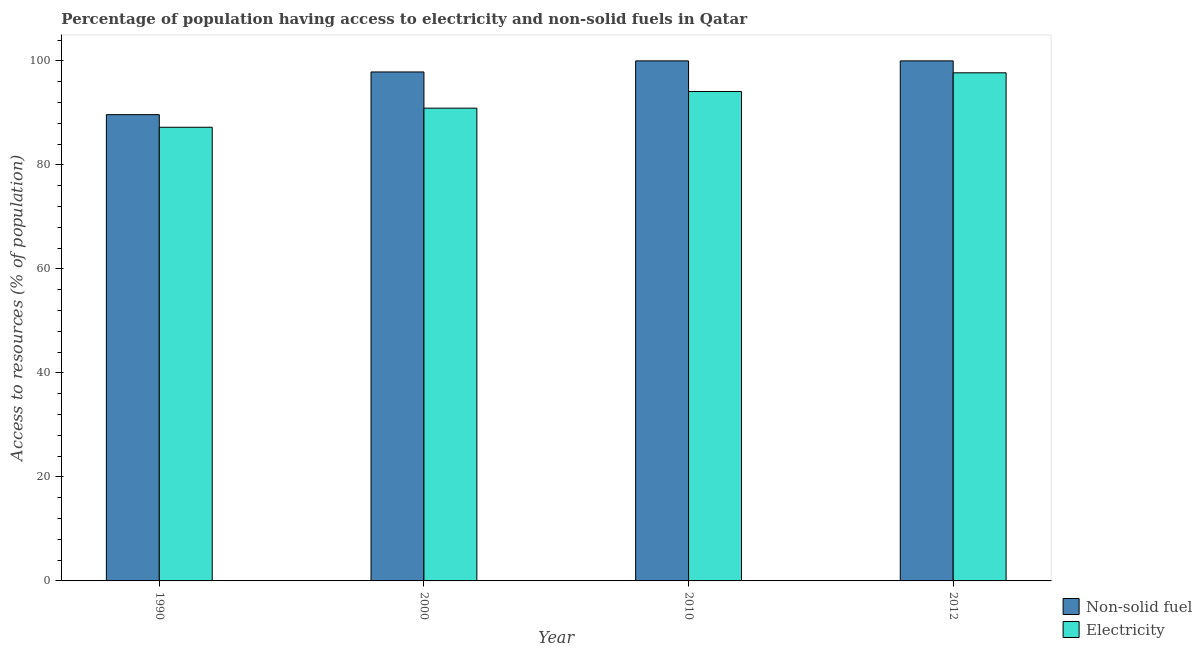How many bars are there on the 3rd tick from the left?
Keep it short and to the point. 2. What is the label of the 1st group of bars from the left?
Make the answer very short. 1990. In how many cases, is the number of bars for a given year not equal to the number of legend labels?
Keep it short and to the point. 0. What is the percentage of population having access to electricity in 2000?
Provide a short and direct response. 90.9. Across all years, what is the maximum percentage of population having access to non-solid fuel?
Your response must be concise. 99.99. Across all years, what is the minimum percentage of population having access to electricity?
Provide a short and direct response. 87.23. What is the total percentage of population having access to non-solid fuel in the graph?
Ensure brevity in your answer.  387.49. What is the difference between the percentage of population having access to non-solid fuel in 2010 and that in 2012?
Keep it short and to the point. 0. What is the difference between the percentage of population having access to non-solid fuel in 1990 and the percentage of population having access to electricity in 2000?
Your answer should be compact. -8.21. What is the average percentage of population having access to non-solid fuel per year?
Your response must be concise. 96.87. In how many years, is the percentage of population having access to electricity greater than 40 %?
Provide a succinct answer. 4. What is the ratio of the percentage of population having access to non-solid fuel in 2000 to that in 2012?
Provide a succinct answer. 0.98. Is the difference between the percentage of population having access to non-solid fuel in 1990 and 2000 greater than the difference between the percentage of population having access to electricity in 1990 and 2000?
Make the answer very short. No. What is the difference between the highest and the second highest percentage of population having access to electricity?
Make the answer very short. 3.6. What is the difference between the highest and the lowest percentage of population having access to electricity?
Provide a short and direct response. 10.47. What does the 2nd bar from the left in 1990 represents?
Give a very brief answer. Electricity. What does the 2nd bar from the right in 1990 represents?
Your response must be concise. Non-solid fuel. How many years are there in the graph?
Offer a terse response. 4. What is the difference between two consecutive major ticks on the Y-axis?
Give a very brief answer. 20. Does the graph contain grids?
Ensure brevity in your answer.  No. Where does the legend appear in the graph?
Offer a terse response. Bottom right. How are the legend labels stacked?
Provide a short and direct response. Vertical. What is the title of the graph?
Give a very brief answer. Percentage of population having access to electricity and non-solid fuels in Qatar. What is the label or title of the X-axis?
Ensure brevity in your answer.  Year. What is the label or title of the Y-axis?
Ensure brevity in your answer.  Access to resources (% of population). What is the Access to resources (% of population) in Non-solid fuel in 1990?
Offer a terse response. 89.65. What is the Access to resources (% of population) of Electricity in 1990?
Keep it short and to the point. 87.23. What is the Access to resources (% of population) of Non-solid fuel in 2000?
Your answer should be compact. 97.86. What is the Access to resources (% of population) of Electricity in 2000?
Offer a very short reply. 90.9. What is the Access to resources (% of population) of Non-solid fuel in 2010?
Give a very brief answer. 99.99. What is the Access to resources (% of population) in Electricity in 2010?
Your answer should be compact. 94.1. What is the Access to resources (% of population) in Non-solid fuel in 2012?
Provide a short and direct response. 99.99. What is the Access to resources (% of population) of Electricity in 2012?
Keep it short and to the point. 97.7. Across all years, what is the maximum Access to resources (% of population) in Non-solid fuel?
Offer a very short reply. 99.99. Across all years, what is the maximum Access to resources (% of population) in Electricity?
Offer a terse response. 97.7. Across all years, what is the minimum Access to resources (% of population) in Non-solid fuel?
Offer a terse response. 89.65. Across all years, what is the minimum Access to resources (% of population) in Electricity?
Ensure brevity in your answer.  87.23. What is the total Access to resources (% of population) of Non-solid fuel in the graph?
Give a very brief answer. 387.49. What is the total Access to resources (% of population) in Electricity in the graph?
Give a very brief answer. 369.92. What is the difference between the Access to resources (% of population) of Non-solid fuel in 1990 and that in 2000?
Your answer should be compact. -8.21. What is the difference between the Access to resources (% of population) in Electricity in 1990 and that in 2000?
Keep it short and to the point. -3.67. What is the difference between the Access to resources (% of population) in Non-solid fuel in 1990 and that in 2010?
Give a very brief answer. -10.34. What is the difference between the Access to resources (% of population) in Electricity in 1990 and that in 2010?
Give a very brief answer. -6.87. What is the difference between the Access to resources (% of population) of Non-solid fuel in 1990 and that in 2012?
Your response must be concise. -10.34. What is the difference between the Access to resources (% of population) of Electricity in 1990 and that in 2012?
Make the answer very short. -10.47. What is the difference between the Access to resources (% of population) in Non-solid fuel in 2000 and that in 2010?
Offer a very short reply. -2.13. What is the difference between the Access to resources (% of population) in Electricity in 2000 and that in 2010?
Provide a succinct answer. -3.2. What is the difference between the Access to resources (% of population) in Non-solid fuel in 2000 and that in 2012?
Keep it short and to the point. -2.13. What is the difference between the Access to resources (% of population) of Electricity in 2000 and that in 2012?
Your answer should be compact. -6.8. What is the difference between the Access to resources (% of population) of Non-solid fuel in 2010 and that in 2012?
Give a very brief answer. 0. What is the difference between the Access to resources (% of population) in Electricity in 2010 and that in 2012?
Ensure brevity in your answer.  -3.6. What is the difference between the Access to resources (% of population) in Non-solid fuel in 1990 and the Access to resources (% of population) in Electricity in 2000?
Provide a short and direct response. -1.25. What is the difference between the Access to resources (% of population) in Non-solid fuel in 1990 and the Access to resources (% of population) in Electricity in 2010?
Provide a short and direct response. -4.45. What is the difference between the Access to resources (% of population) in Non-solid fuel in 1990 and the Access to resources (% of population) in Electricity in 2012?
Provide a succinct answer. -8.05. What is the difference between the Access to resources (% of population) in Non-solid fuel in 2000 and the Access to resources (% of population) in Electricity in 2010?
Your answer should be compact. 3.76. What is the difference between the Access to resources (% of population) of Non-solid fuel in 2000 and the Access to resources (% of population) of Electricity in 2012?
Give a very brief answer. 0.16. What is the difference between the Access to resources (% of population) of Non-solid fuel in 2010 and the Access to resources (% of population) of Electricity in 2012?
Offer a terse response. 2.29. What is the average Access to resources (% of population) in Non-solid fuel per year?
Your response must be concise. 96.87. What is the average Access to resources (% of population) of Electricity per year?
Offer a terse response. 92.48. In the year 1990, what is the difference between the Access to resources (% of population) in Non-solid fuel and Access to resources (% of population) in Electricity?
Provide a short and direct response. 2.42. In the year 2000, what is the difference between the Access to resources (% of population) in Non-solid fuel and Access to resources (% of population) in Electricity?
Offer a very short reply. 6.96. In the year 2010, what is the difference between the Access to resources (% of population) in Non-solid fuel and Access to resources (% of population) in Electricity?
Your response must be concise. 5.89. In the year 2012, what is the difference between the Access to resources (% of population) in Non-solid fuel and Access to resources (% of population) in Electricity?
Ensure brevity in your answer.  2.29. What is the ratio of the Access to resources (% of population) of Non-solid fuel in 1990 to that in 2000?
Make the answer very short. 0.92. What is the ratio of the Access to resources (% of population) of Electricity in 1990 to that in 2000?
Your response must be concise. 0.96. What is the ratio of the Access to resources (% of population) of Non-solid fuel in 1990 to that in 2010?
Your answer should be compact. 0.9. What is the ratio of the Access to resources (% of population) of Electricity in 1990 to that in 2010?
Provide a succinct answer. 0.93. What is the ratio of the Access to resources (% of population) of Non-solid fuel in 1990 to that in 2012?
Make the answer very short. 0.9. What is the ratio of the Access to resources (% of population) in Electricity in 1990 to that in 2012?
Keep it short and to the point. 0.89. What is the ratio of the Access to resources (% of population) of Non-solid fuel in 2000 to that in 2010?
Your response must be concise. 0.98. What is the ratio of the Access to resources (% of population) of Electricity in 2000 to that in 2010?
Your answer should be compact. 0.97. What is the ratio of the Access to resources (% of population) in Non-solid fuel in 2000 to that in 2012?
Ensure brevity in your answer.  0.98. What is the ratio of the Access to resources (% of population) of Electricity in 2000 to that in 2012?
Your response must be concise. 0.93. What is the ratio of the Access to resources (% of population) in Electricity in 2010 to that in 2012?
Your response must be concise. 0.96. What is the difference between the highest and the second highest Access to resources (% of population) of Non-solid fuel?
Keep it short and to the point. 0. What is the difference between the highest and the second highest Access to resources (% of population) of Electricity?
Your response must be concise. 3.6. What is the difference between the highest and the lowest Access to resources (% of population) in Non-solid fuel?
Ensure brevity in your answer.  10.34. What is the difference between the highest and the lowest Access to resources (% of population) of Electricity?
Provide a succinct answer. 10.47. 